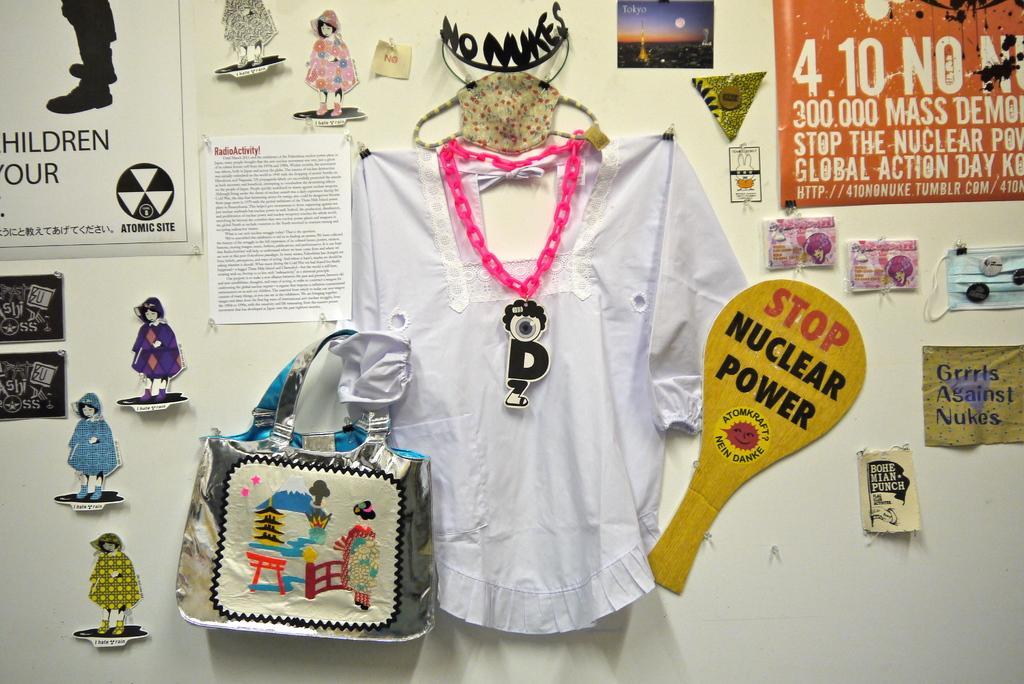Please provide a concise description of this image. This picture is of inside the room. We can see a wall and there is a white color t-shirt, bag hanging on the wall and a banner, some posters with some text on it are attached to the wall and there is a picture containing the sky, moon and skyscrapers. 